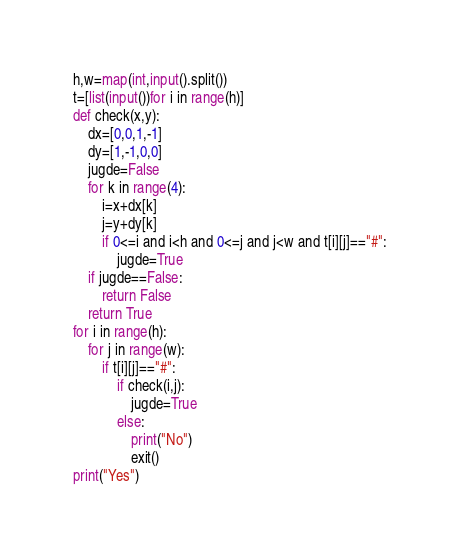<code> <loc_0><loc_0><loc_500><loc_500><_Python_>h,w=map(int,input().split())
t=[list(input())for i in range(h)]
def check(x,y):
    dx=[0,0,1,-1]
    dy=[1,-1,0,0]
    jugde=False
    for k in range(4):
        i=x+dx[k]
        j=y+dy[k]
        if 0<=i and i<h and 0<=j and j<w and t[i][j]=="#":
            jugde=True
    if jugde==False:
        return False
    return True
for i in range(h):
    for j in range(w):
        if t[i][j]=="#":
            if check(i,j):
                jugde=True
            else:
                print("No")
                exit()
print("Yes")
</code> 